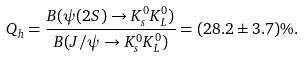<formula> <loc_0><loc_0><loc_500><loc_500>Q _ { h } = \frac { B ( \psi ( 2 S ) \rightarrow K _ { s } ^ { 0 } K _ { L } ^ { 0 } ) } { B ( J / \psi \rightarrow K _ { s } ^ { 0 } K _ { L } ^ { 0 } ) } = ( 2 8 . 2 \pm 3 . 7 ) \% .</formula> 